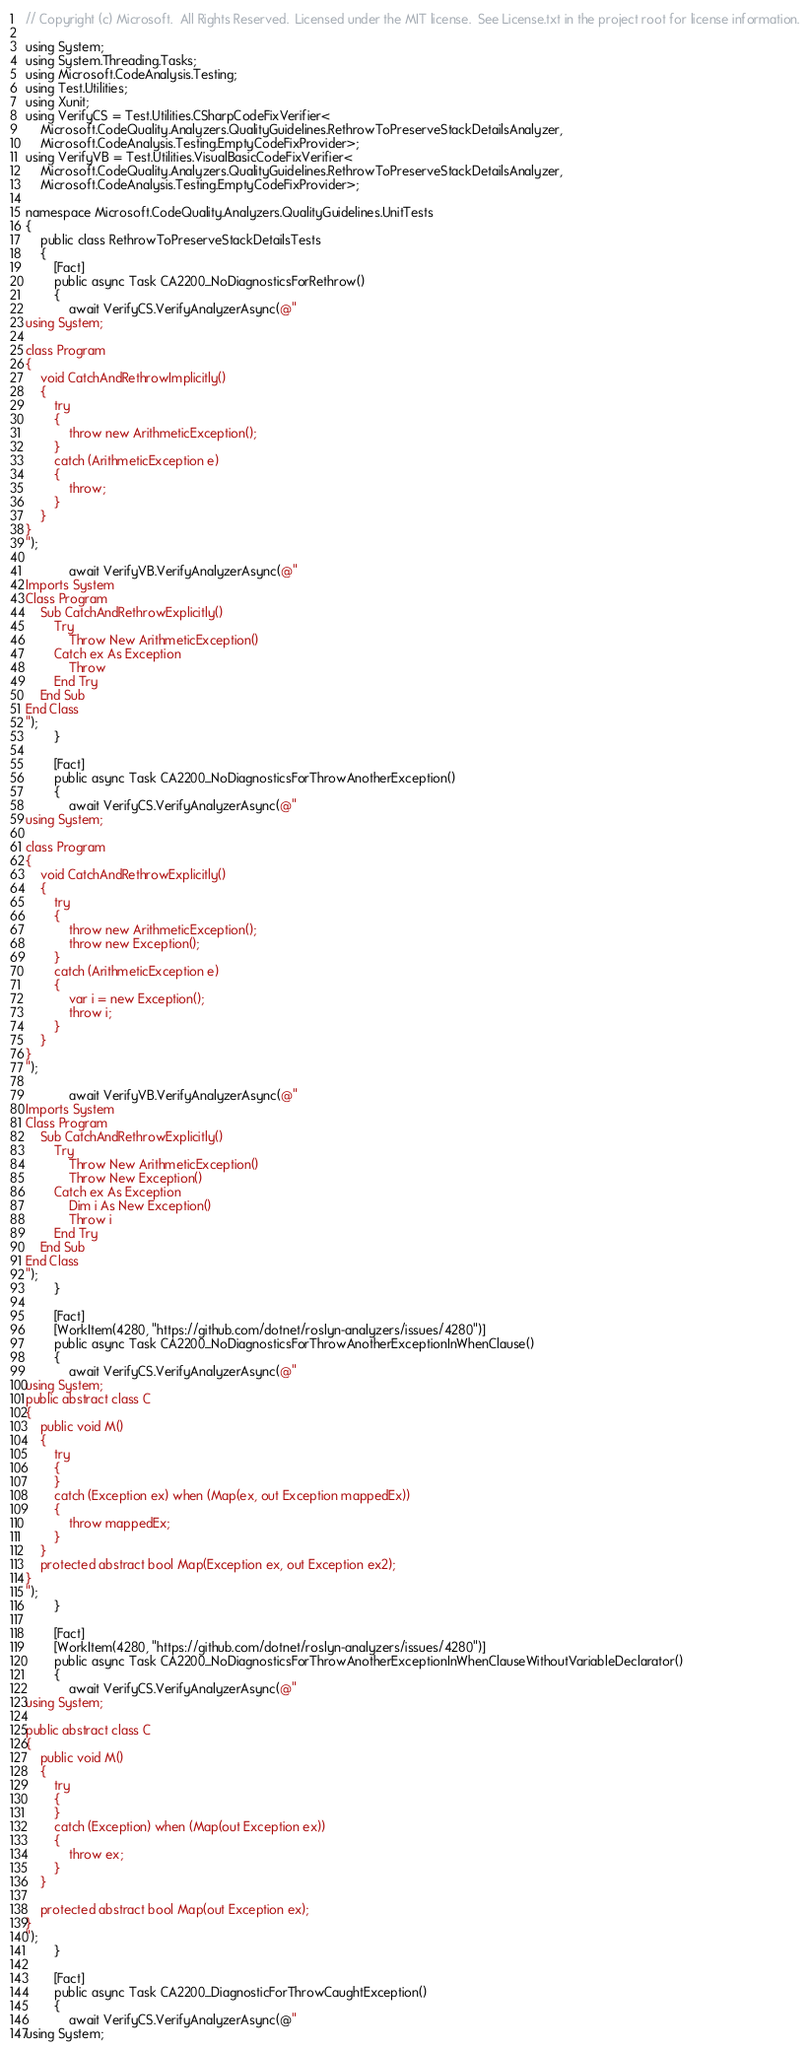<code> <loc_0><loc_0><loc_500><loc_500><_C#_>// Copyright (c) Microsoft.  All Rights Reserved.  Licensed under the MIT license.  See License.txt in the project root for license information.

using System;
using System.Threading.Tasks;
using Microsoft.CodeAnalysis.Testing;
using Test.Utilities;
using Xunit;
using VerifyCS = Test.Utilities.CSharpCodeFixVerifier<
    Microsoft.CodeQuality.Analyzers.QualityGuidelines.RethrowToPreserveStackDetailsAnalyzer,
    Microsoft.CodeAnalysis.Testing.EmptyCodeFixProvider>;
using VerifyVB = Test.Utilities.VisualBasicCodeFixVerifier<
    Microsoft.CodeQuality.Analyzers.QualityGuidelines.RethrowToPreserveStackDetailsAnalyzer,
    Microsoft.CodeAnalysis.Testing.EmptyCodeFixProvider>;

namespace Microsoft.CodeQuality.Analyzers.QualityGuidelines.UnitTests
{
    public class RethrowToPreserveStackDetailsTests
    {
        [Fact]
        public async Task CA2200_NoDiagnosticsForRethrow()
        {
            await VerifyCS.VerifyAnalyzerAsync(@"
using System;

class Program
{
    void CatchAndRethrowImplicitly()
    {
        try
        {
            throw new ArithmeticException();
        }
        catch (ArithmeticException e)
        { 
            throw;
        }
    }
}
");

            await VerifyVB.VerifyAnalyzerAsync(@"
Imports System
Class Program
    Sub CatchAndRethrowExplicitly()
        Try
            Throw New ArithmeticException()
        Catch ex As Exception
            Throw
        End Try
    End Sub
End Class
");
        }

        [Fact]
        public async Task CA2200_NoDiagnosticsForThrowAnotherException()
        {
            await VerifyCS.VerifyAnalyzerAsync(@"
using System;

class Program
{
    void CatchAndRethrowExplicitly()
    {
        try
        {
            throw new ArithmeticException();
            throw new Exception();
        }
        catch (ArithmeticException e)
        {
            var i = new Exception();
            throw i;
        }
    }
}
");

            await VerifyVB.VerifyAnalyzerAsync(@"
Imports System
Class Program
    Sub CatchAndRethrowExplicitly()
        Try
            Throw New ArithmeticException()
            Throw New Exception()
        Catch ex As Exception
            Dim i As New Exception()
            Throw i
        End Try
    End Sub
End Class
");
        }

        [Fact]
        [WorkItem(4280, "https://github.com/dotnet/roslyn-analyzers/issues/4280")]
        public async Task CA2200_NoDiagnosticsForThrowAnotherExceptionInWhenClause()
        {
            await VerifyCS.VerifyAnalyzerAsync(@"
using System;
public abstract class C
{
    public void M()
    {
        try
        {
        }
        catch (Exception ex) when (Map(ex, out Exception mappedEx))
        {
            throw mappedEx;
        }
    }
    protected abstract bool Map(Exception ex, out Exception ex2);
}
");
        }

        [Fact]
        [WorkItem(4280, "https://github.com/dotnet/roslyn-analyzers/issues/4280")]
        public async Task CA2200_NoDiagnosticsForThrowAnotherExceptionInWhenClauseWithoutVariableDeclarator()
        {
            await VerifyCS.VerifyAnalyzerAsync(@"
using System;

public abstract class C
{
    public void M()
    {
        try
        {
        }
        catch (Exception) when (Map(out Exception ex))
        {
            throw ex;
        }
    }

    protected abstract bool Map(out Exception ex);
}
");
        }

        [Fact]
        public async Task CA2200_DiagnosticForThrowCaughtException()
        {
            await VerifyCS.VerifyAnalyzerAsync(@"
using System;
</code> 